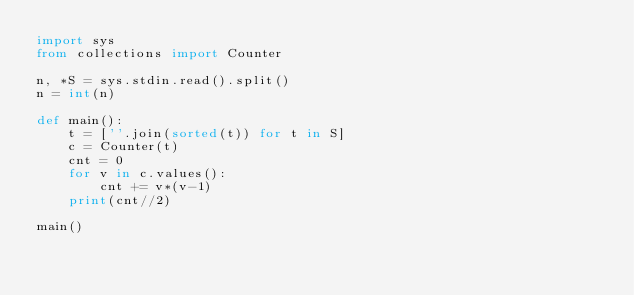Convert code to text. <code><loc_0><loc_0><loc_500><loc_500><_Python_>import sys
from collections import Counter

n, *S = sys.stdin.read().split()
n = int(n)

def main():
    t = [''.join(sorted(t)) for t in S]
    c = Counter(t)
    cnt = 0
    for v in c.values():
        cnt += v*(v-1)
    print(cnt//2)

main()
</code> 